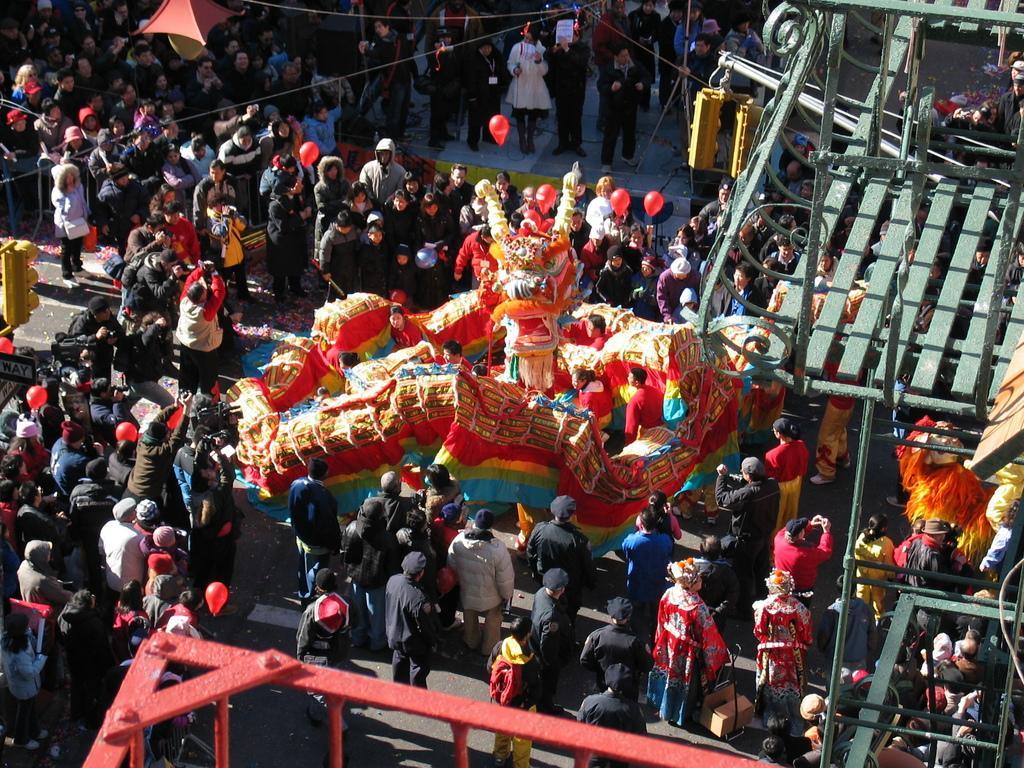In one or two sentences, can you explain what this image depicts? This picture shows few people standing on the road and we see a jumping balloon and a metal fence and we see toy balloons and signal lights. 